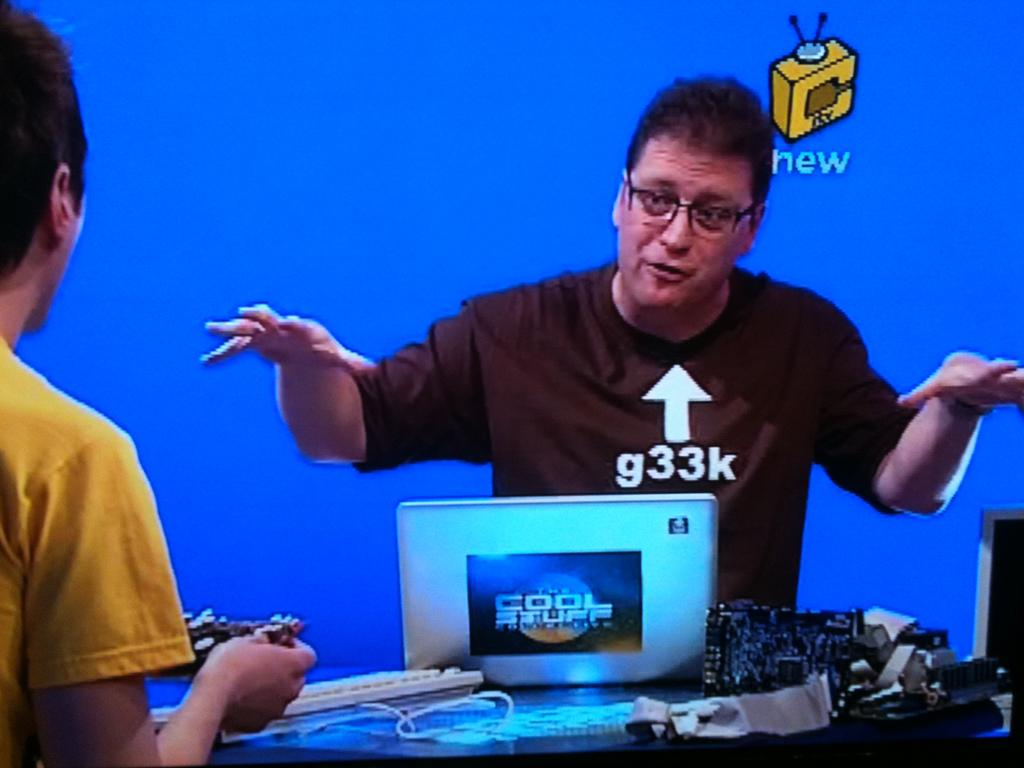<image>
Give a short and clear explanation of the subsequent image. Man with glasses wearing a shirt that says g33k. 